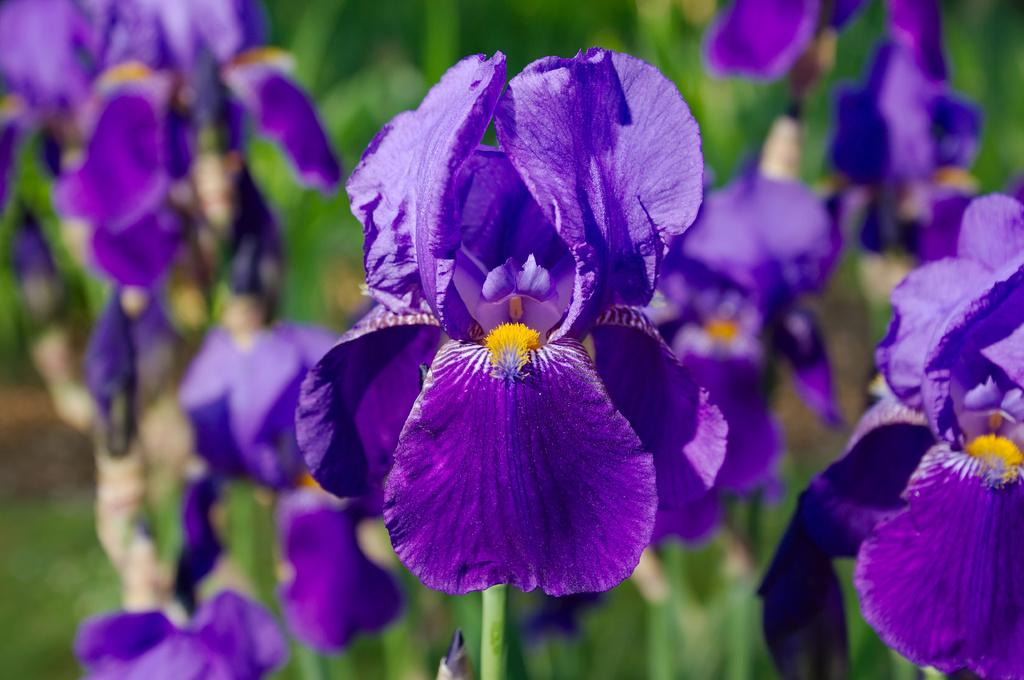What types of living organisms can be seen in the image? There are many plants in the image. What specific features can be observed on the plants? There are flowers on the plants. Can you describe the background of the image? The background of the image is blurred. What type of rock is being held by the dad in the image? There is no dad or rock present in the image; it features many plants with flowers and a blurred background. 